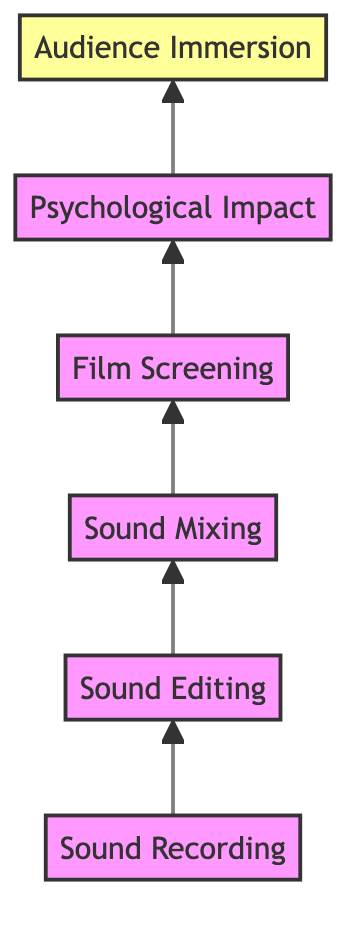What is the first stage in the flow chart? The first stage is "Sound Recording," as it is the starting point of the process leading towards audience immersion.
Answer: Sound Recording How many stages are involved in this flow chart? There are six stages depicted in the flow chart, from "Sound Recording" to "Audience Immersion."
Answer: 6 Which stage directly follows "Sound Editing"? The stage that directly follows "Sound Editing" is "Sound Mixing," as indicated by the arrow pointing upwards to the next element in the flow.
Answer: Sound Mixing What is the last stage in the flow chart? The last stage is "Audience Immersion," which represents the culmination of the effects of Foley on viewers.
Answer: Audience Immersion How does "Sound Mixing" relate to "Film Screening"? "Sound Mixing" precedes "Film Screening" in the diagram, indicating that the mixing of sounds occurs before the film is screened to the audience.
Answer: precedes What is the psychological aspect evaluated before gauging audience immersion? The psychological aspect evaluated before audience immersion is "Psychological Impact," which assesses how Foley sounds contribute to emotional depth.
Answer: Psychological Impact Which two stages are directly connected with an upward arrow? "Sound Editing" and "Sound Mixing" are directly connected with an upward arrow, indicating the flow from one to the other.
Answer: Sound Editing and Sound Mixing What can be inferred about audience engagement from this flow chart? The flow chart suggests that effective Foley integration, ending with "Audience Immersion," enhances overall audience engagement and involvement with the film.
Answer: effective Foley integration enhances engagement What is the relationship between "Film Screening" and "Psychological Impact"? "Film Screening" leads to the evaluation of "Psychological Impact," indicating that screening with Foley allows analysis of its emotional effects on the audience.
Answer: leads to 